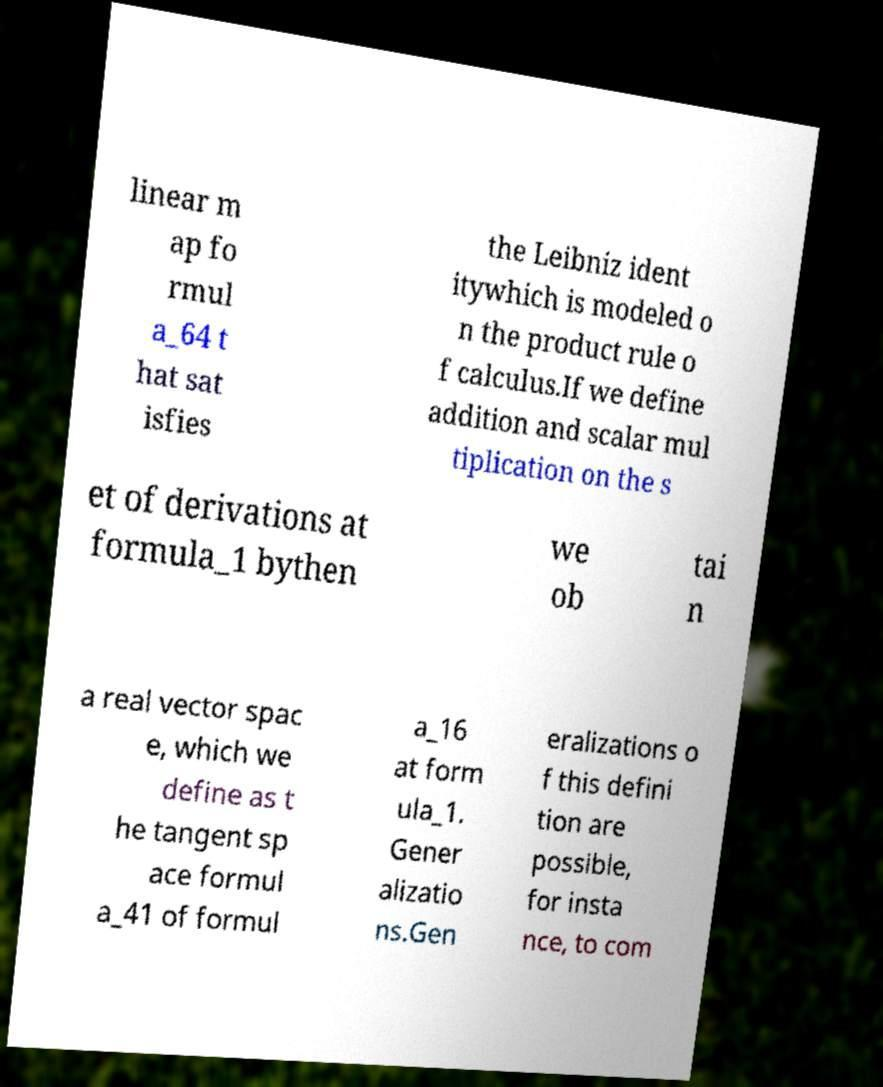Can you read and provide the text displayed in the image?This photo seems to have some interesting text. Can you extract and type it out for me? linear m ap fo rmul a_64 t hat sat isfies the Leibniz ident itywhich is modeled o n the product rule o f calculus.If we define addition and scalar mul tiplication on the s et of derivations at formula_1 bythen we ob tai n a real vector spac e, which we define as t he tangent sp ace formul a_41 of formul a_16 at form ula_1. Gener alizatio ns.Gen eralizations o f this defini tion are possible, for insta nce, to com 